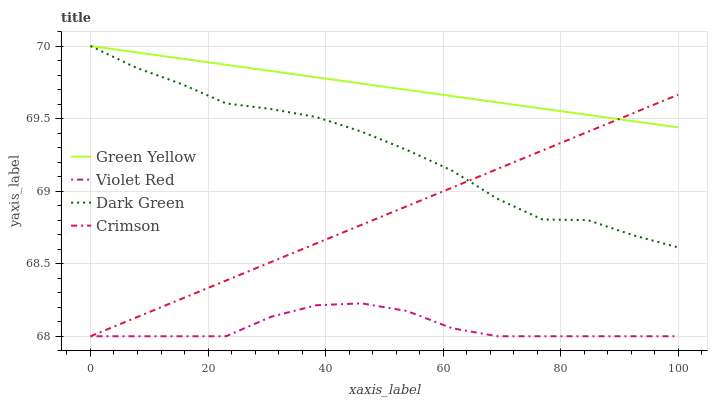Does Green Yellow have the minimum area under the curve?
Answer yes or no. No. Does Violet Red have the maximum area under the curve?
Answer yes or no. No. Is Violet Red the smoothest?
Answer yes or no. No. Is Violet Red the roughest?
Answer yes or no. No. Does Green Yellow have the lowest value?
Answer yes or no. No. Does Violet Red have the highest value?
Answer yes or no. No. Is Violet Red less than Dark Green?
Answer yes or no. Yes. Is Green Yellow greater than Violet Red?
Answer yes or no. Yes. Does Violet Red intersect Dark Green?
Answer yes or no. No. 